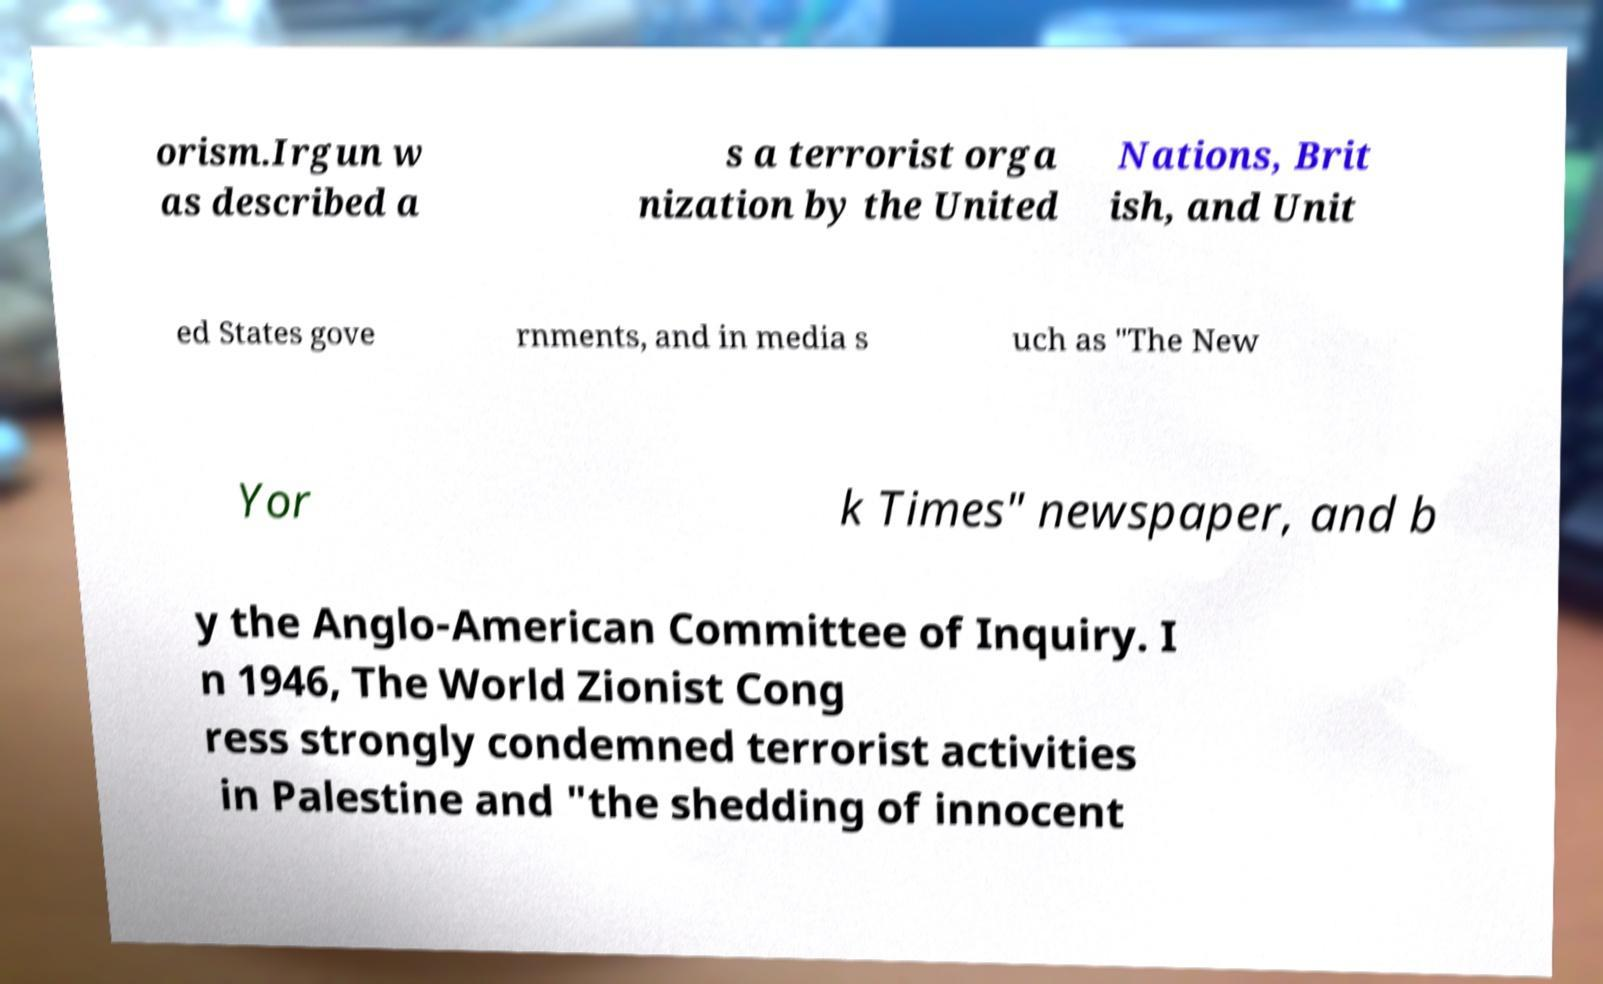Could you extract and type out the text from this image? orism.Irgun w as described a s a terrorist orga nization by the United Nations, Brit ish, and Unit ed States gove rnments, and in media s uch as "The New Yor k Times" newspaper, and b y the Anglo-American Committee of Inquiry. I n 1946, The World Zionist Cong ress strongly condemned terrorist activities in Palestine and "the shedding of innocent 